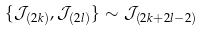<formula> <loc_0><loc_0><loc_500><loc_500>\{ \mathcal { J } _ { ( 2 k ) } , \mathcal { J } _ { ( 2 l ) } \} \sim \mathcal { J } _ { ( 2 k + 2 l - 2 ) }</formula> 